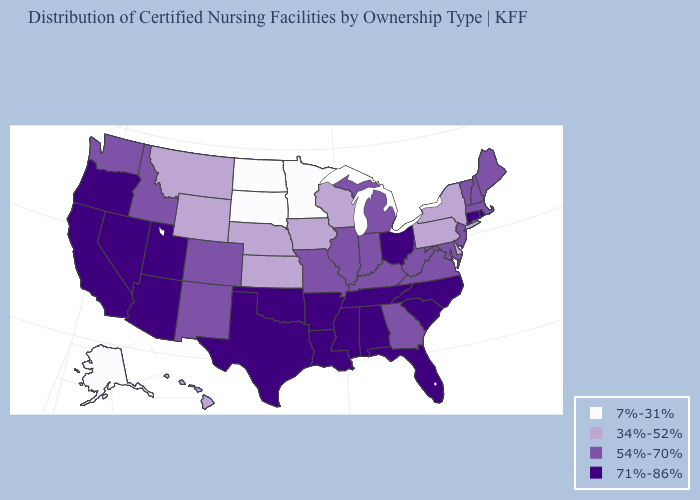What is the value of Rhode Island?
Be succinct. 71%-86%. Does the first symbol in the legend represent the smallest category?
Give a very brief answer. Yes. What is the lowest value in the USA?
Be succinct. 7%-31%. What is the value of Oregon?
Write a very short answer. 71%-86%. Name the states that have a value in the range 71%-86%?
Keep it brief. Alabama, Arizona, Arkansas, California, Connecticut, Florida, Louisiana, Mississippi, Nevada, North Carolina, Ohio, Oklahoma, Oregon, Rhode Island, South Carolina, Tennessee, Texas, Utah. Name the states that have a value in the range 71%-86%?
Short answer required. Alabama, Arizona, Arkansas, California, Connecticut, Florida, Louisiana, Mississippi, Nevada, North Carolina, Ohio, Oklahoma, Oregon, Rhode Island, South Carolina, Tennessee, Texas, Utah. Among the states that border Florida , which have the lowest value?
Quick response, please. Georgia. Name the states that have a value in the range 71%-86%?
Quick response, please. Alabama, Arizona, Arkansas, California, Connecticut, Florida, Louisiana, Mississippi, Nevada, North Carolina, Ohio, Oklahoma, Oregon, Rhode Island, South Carolina, Tennessee, Texas, Utah. What is the value of North Carolina?
Answer briefly. 71%-86%. Does West Virginia have the lowest value in the USA?
Concise answer only. No. Name the states that have a value in the range 54%-70%?
Concise answer only. Colorado, Georgia, Idaho, Illinois, Indiana, Kentucky, Maine, Maryland, Massachusetts, Michigan, Missouri, New Hampshire, New Jersey, New Mexico, Vermont, Virginia, Washington, West Virginia. Among the states that border South Carolina , which have the lowest value?
Quick response, please. Georgia. What is the value of Utah?
Concise answer only. 71%-86%. What is the lowest value in the USA?
Quick response, please. 7%-31%. 